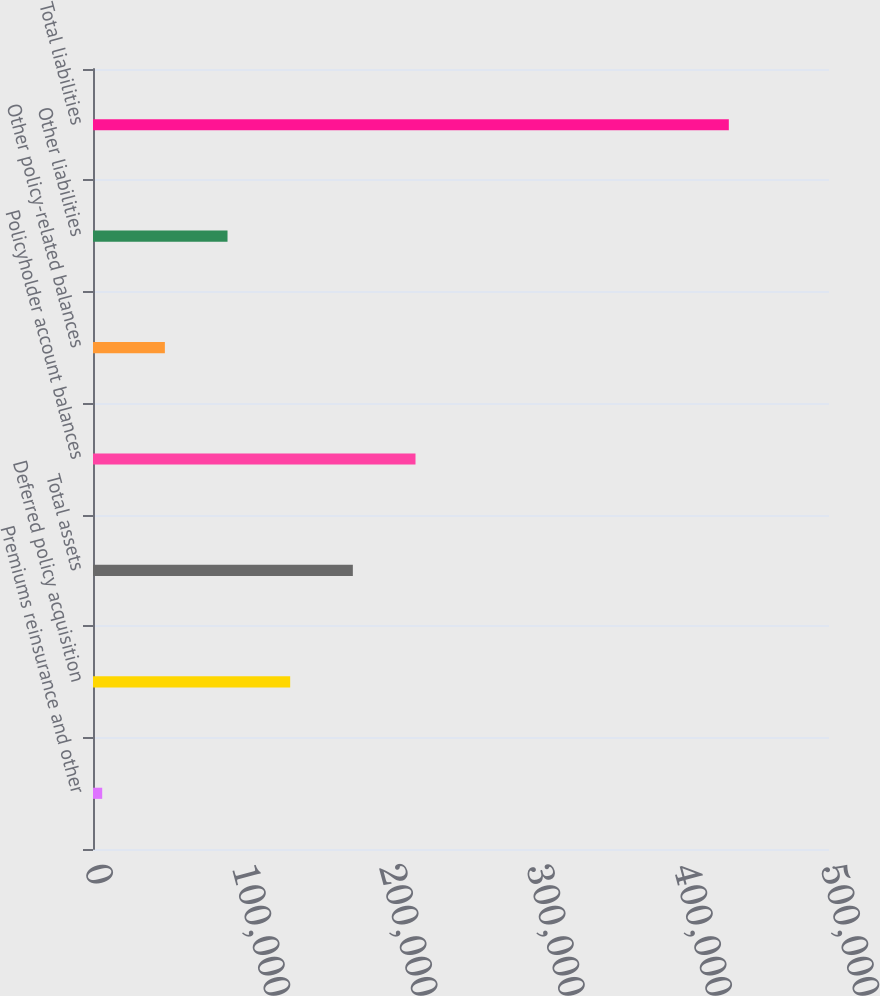<chart> <loc_0><loc_0><loc_500><loc_500><bar_chart><fcel>Premiums reinsurance and other<fcel>Deferred policy acquisition<fcel>Total assets<fcel>Policyholder account balances<fcel>Other policy-related balances<fcel>Other liabilities<fcel>Total liabilities<nl><fcel>6248<fcel>133958<fcel>176528<fcel>219098<fcel>48817.9<fcel>91387.8<fcel>431947<nl></chart> 